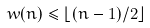Convert formula to latex. <formula><loc_0><loc_0><loc_500><loc_500>w ( n ) \leq \lfloor ( n - 1 ) / 2 \rfloor</formula> 